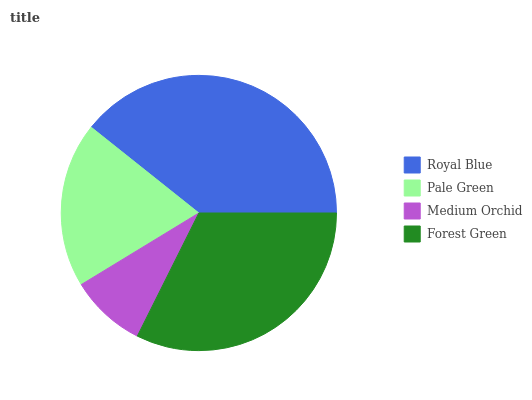Is Medium Orchid the minimum?
Answer yes or no. Yes. Is Royal Blue the maximum?
Answer yes or no. Yes. Is Pale Green the minimum?
Answer yes or no. No. Is Pale Green the maximum?
Answer yes or no. No. Is Royal Blue greater than Pale Green?
Answer yes or no. Yes. Is Pale Green less than Royal Blue?
Answer yes or no. Yes. Is Pale Green greater than Royal Blue?
Answer yes or no. No. Is Royal Blue less than Pale Green?
Answer yes or no. No. Is Forest Green the high median?
Answer yes or no. Yes. Is Pale Green the low median?
Answer yes or no. Yes. Is Royal Blue the high median?
Answer yes or no. No. Is Medium Orchid the low median?
Answer yes or no. No. 